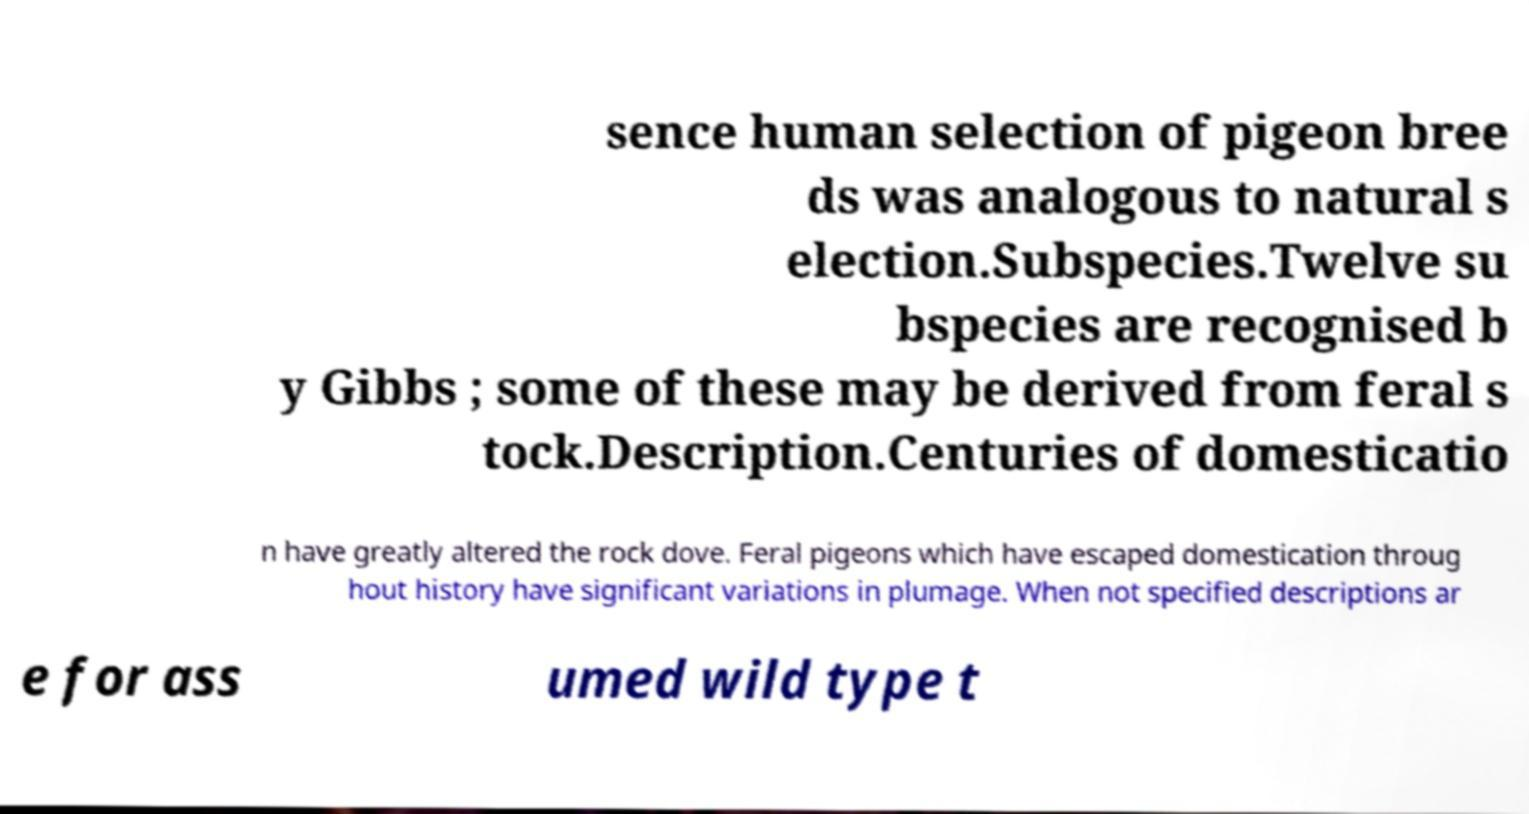Can you read and provide the text displayed in the image?This photo seems to have some interesting text. Can you extract and type it out for me? sence human selection of pigeon bree ds was analogous to natural s election.Subspecies.Twelve su bspecies are recognised b y Gibbs ; some of these may be derived from feral s tock.Description.Centuries of domesticatio n have greatly altered the rock dove. Feral pigeons which have escaped domestication throug hout history have significant variations in plumage. When not specified descriptions ar e for ass umed wild type t 